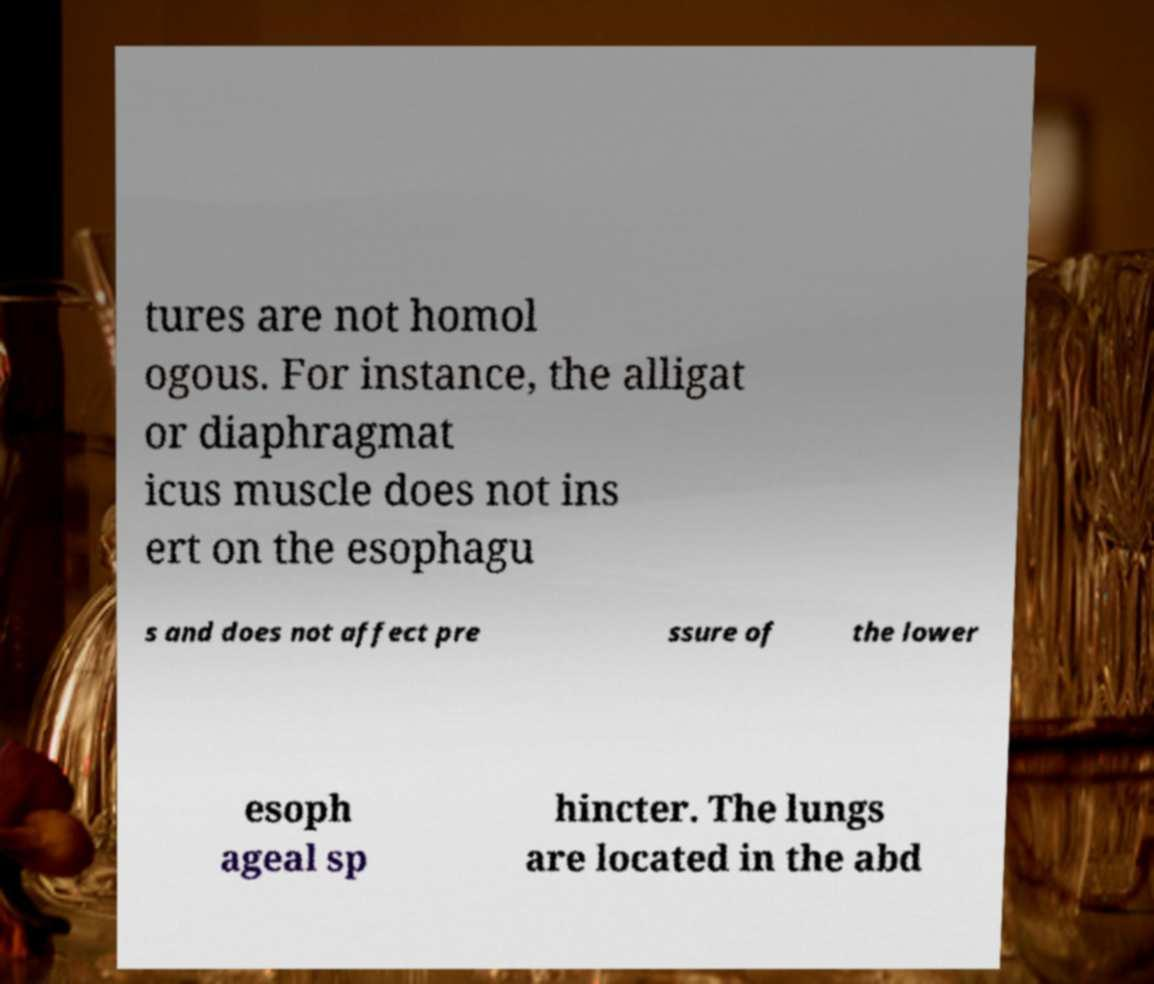What messages or text are displayed in this image? I need them in a readable, typed format. tures are not homol ogous. For instance, the alligat or diaphragmat icus muscle does not ins ert on the esophagu s and does not affect pre ssure of the lower esoph ageal sp hincter. The lungs are located in the abd 